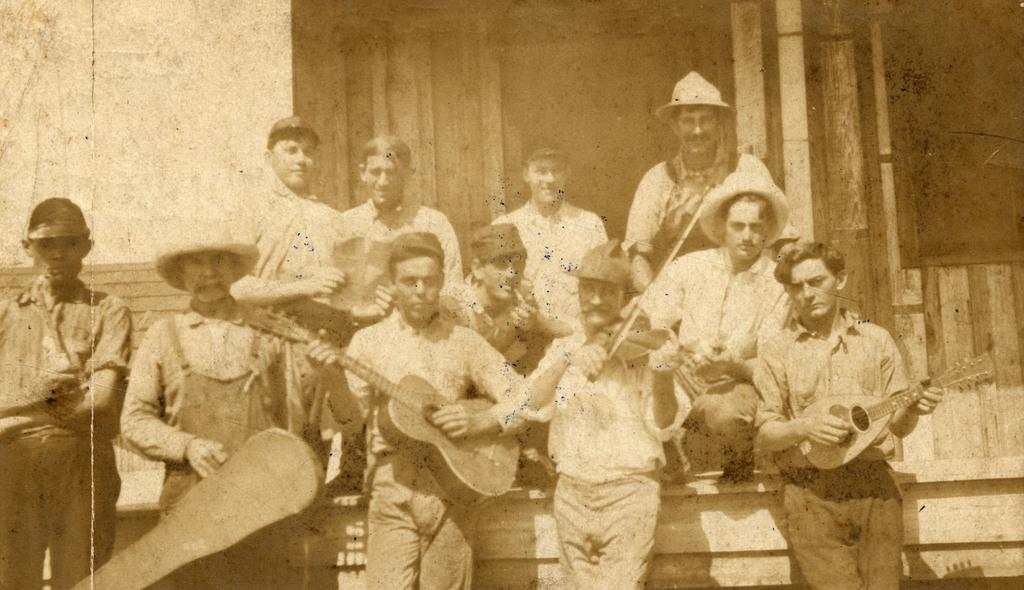What is the color scheme of the image? The image is black and white. What are the people in the image doing? The people in the image are posing for a camera. Are any of the people holding specific objects in the image? Yes, some people are holding musical instruments. What are the people wearing on their heads in the image? All persons in the image are wearing caps. What type of soap is being used by the people in the image? There is no soap present in the image; it features people posing for a camera, some of whom are holding musical instruments and wearing caps. Can you tell me how many people are whistling in the image? There is no whistling activity depicted in the image. 